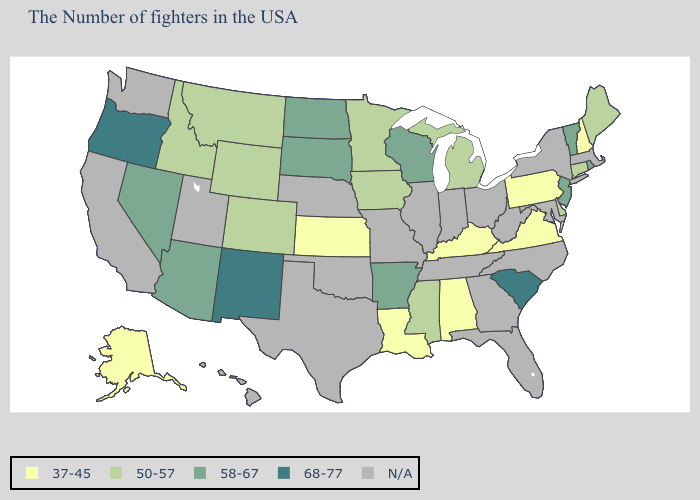What is the value of Oregon?
Concise answer only. 68-77. What is the lowest value in states that border Iowa?
Short answer required. 50-57. What is the value of North Carolina?
Be succinct. N/A. Which states hav the highest value in the MidWest?
Short answer required. Wisconsin, South Dakota, North Dakota. Name the states that have a value in the range N/A?
Answer briefly. Massachusetts, New York, Maryland, North Carolina, West Virginia, Ohio, Florida, Georgia, Indiana, Tennessee, Illinois, Missouri, Nebraska, Oklahoma, Texas, Utah, California, Washington, Hawaii. Which states hav the highest value in the West?
Answer briefly. New Mexico, Oregon. Among the states that border Oregon , does Idaho have the highest value?
Quick response, please. No. Name the states that have a value in the range 58-67?
Be succinct. Rhode Island, Vermont, New Jersey, Wisconsin, Arkansas, South Dakota, North Dakota, Arizona, Nevada. What is the value of Indiana?
Concise answer only. N/A. What is the value of Iowa?
Keep it brief. 50-57. Name the states that have a value in the range 58-67?
Write a very short answer. Rhode Island, Vermont, New Jersey, Wisconsin, Arkansas, South Dakota, North Dakota, Arizona, Nevada. Does the map have missing data?
Give a very brief answer. Yes. Name the states that have a value in the range N/A?
Be succinct. Massachusetts, New York, Maryland, North Carolina, West Virginia, Ohio, Florida, Georgia, Indiana, Tennessee, Illinois, Missouri, Nebraska, Oklahoma, Texas, Utah, California, Washington, Hawaii. 